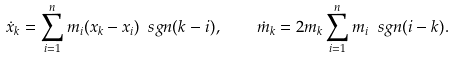Convert formula to latex. <formula><loc_0><loc_0><loc_500><loc_500>\dot { x } _ { k } = \sum _ { i = 1 } ^ { n } m _ { i } ( x _ { k } - x _ { i } ) \ s g n ( k - i ) , \quad \dot { m } _ { k } = 2 m _ { k } \sum _ { i = 1 } ^ { n } m _ { i } \ s g n ( i - k ) .</formula> 